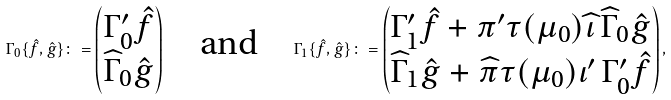Convert formula to latex. <formula><loc_0><loc_0><loc_500><loc_500>\Gamma _ { 0 } \{ \hat { f } , \hat { g } \} \colon = \begin{pmatrix} \Gamma _ { 0 } ^ { \prime } \hat { f } \\ \widehat { \Gamma } _ { 0 } \hat { g } \end{pmatrix} \quad \text {and} \quad \Gamma _ { 1 } \{ \hat { f } , \hat { g } \} \colon = \begin{pmatrix} \Gamma _ { 1 } ^ { \prime } \hat { f } + \pi ^ { \prime } \tau ( \mu _ { 0 } ) \widehat { \iota } \, \widehat { \Gamma } _ { 0 } \hat { g } \\ \widehat { \Gamma } _ { 1 } \hat { g } + \widehat { \pi } \tau ( \mu _ { 0 } ) \iota ^ { \prime } \, \Gamma _ { 0 } ^ { \prime } \hat { f } \end{pmatrix} ,</formula> 